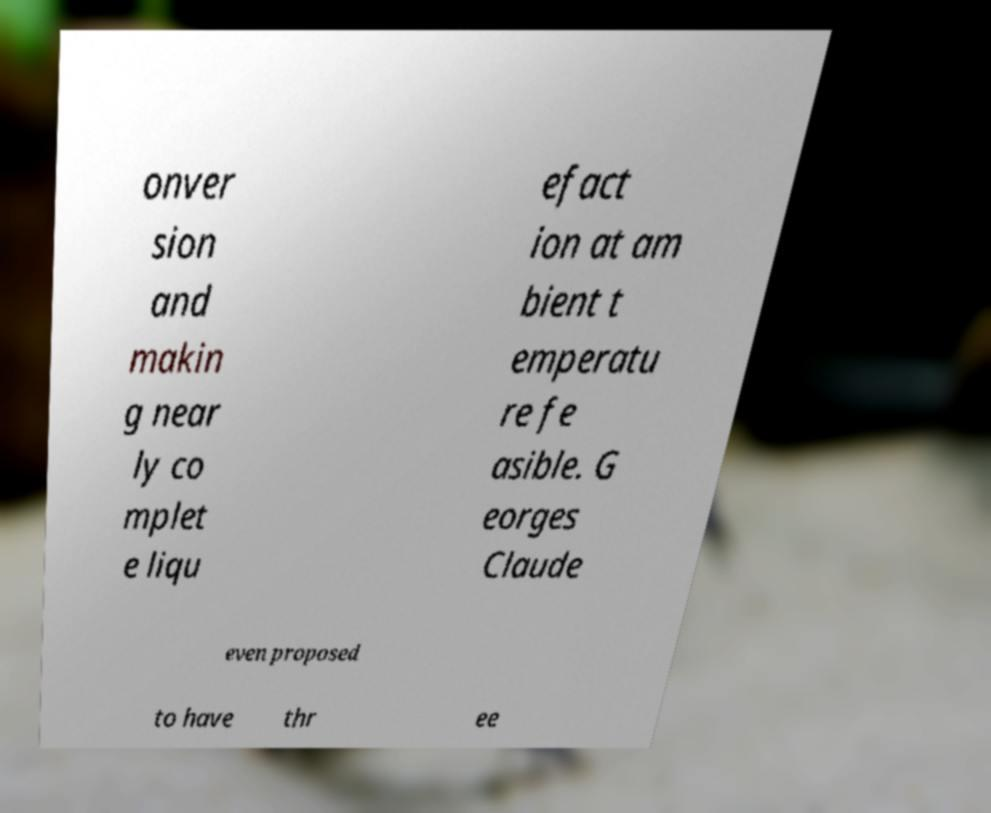Could you assist in decoding the text presented in this image and type it out clearly? onver sion and makin g near ly co mplet e liqu efact ion at am bient t emperatu re fe asible. G eorges Claude even proposed to have thr ee 